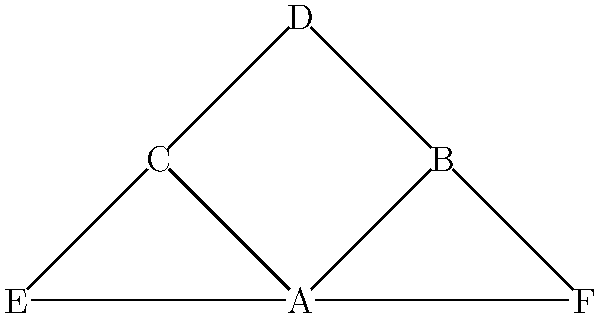In the context of Polish political party coalitions, consider the graph above where nodes represent political parties and edges represent coalition agreements. Which party acts as the most crucial mediator in this coalition structure, and what type of centrality measure would best identify this party? To answer this question, we need to follow these steps:

1. Understand the concept of centrality in network analysis:
   Centrality measures help identify the most important nodes in a graph.

2. Identify the relevant centrality measure:
   For mediating roles, betweenness centrality is most appropriate. It measures how often a node appears on the shortest paths between other nodes.

3. Analyze the graph structure:
   - Party A is connected to 4 other parties (B, C, E, F)
   - Parties B and C are connected to 3 parties each (A, D, and F or E respectively)
   - Parties D, E, and F are connected to 2 parties each

4. Calculate betweenness centrality (simplified):
   Party A appears on the most shortest paths between other parties, acting as a bridge between:
   - B and C
   - B and E
   - C and F
   - E and F

5. Interpret the results:
   Party A has the highest betweenness centrality, making it the most crucial mediator in this coalition structure.

6. Relate to Polish political context:
   This structure could represent a centrist party (A) mediating between left-leaning (B, D) and right-leaning (C, E, F) parties in the Polish political landscape.
Answer: Party A; betweenness centrality 